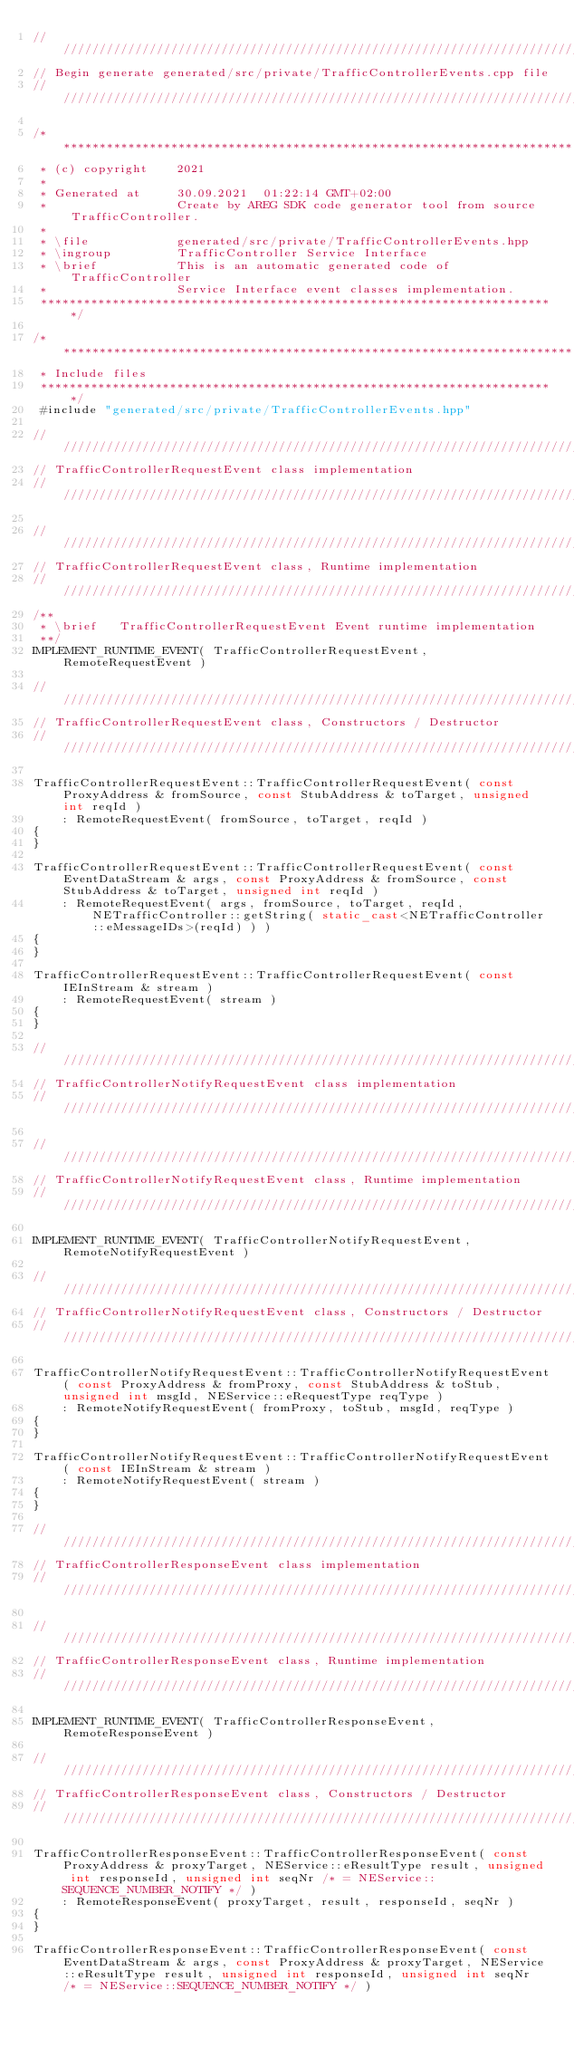<code> <loc_0><loc_0><loc_500><loc_500><_C++_>//////////////////////////////////////////////////////////////////////////
// Begin generate generated/src/private/TrafficControllerEvents.cpp file
//////////////////////////////////////////////////////////////////////////

/************************************************************************
 * (c) copyright    2021
 *
 * Generated at     30.09.2021  01:22:14 GMT+02:00 
 *                  Create by AREG SDK code generator tool from source TrafficController.
 *
 * \file            generated/src/private/TrafficControllerEvents.hpp
 * \ingroup         TrafficController Service Interface
 * \brief           This is an automatic generated code of TrafficController
 *                  Service Interface event classes implementation.
 ************************************************************************/

/************************************************************************
 * Include files
 ************************************************************************/
 #include "generated/src/private/TrafficControllerEvents.hpp"
 
//////////////////////////////////////////////////////////////////////////
// TrafficControllerRequestEvent class implementation
//////////////////////////////////////////////////////////////////////////

//////////////////////////////////////////////////////////////////////////
// TrafficControllerRequestEvent class, Runtime implementation
//////////////////////////////////////////////////////////////////////////
/**
 * \brief   TrafficControllerRequestEvent Event runtime implementation
 **/
IMPLEMENT_RUNTIME_EVENT( TrafficControllerRequestEvent, RemoteRequestEvent )

//////////////////////////////////////////////////////////////////////////
// TrafficControllerRequestEvent class, Constructors / Destructor
//////////////////////////////////////////////////////////////////////////

TrafficControllerRequestEvent::TrafficControllerRequestEvent( const ProxyAddress & fromSource, const StubAddress & toTarget, unsigned int reqId )
    : RemoteRequestEvent( fromSource, toTarget, reqId )
{
}

TrafficControllerRequestEvent::TrafficControllerRequestEvent( const EventDataStream & args, const ProxyAddress & fromSource, const StubAddress & toTarget, unsigned int reqId )
    : RemoteRequestEvent( args, fromSource, toTarget, reqId, NETrafficController::getString( static_cast<NETrafficController::eMessageIDs>(reqId) ) )
{
}

TrafficControllerRequestEvent::TrafficControllerRequestEvent( const IEInStream & stream )
    : RemoteRequestEvent( stream )
{
}    

//////////////////////////////////////////////////////////////////////////
// TrafficControllerNotifyRequestEvent class implementation
//////////////////////////////////////////////////////////////////////////

//////////////////////////////////////////////////////////////////////////
// TrafficControllerNotifyRequestEvent class, Runtime implementation
//////////////////////////////////////////////////////////////////////////

IMPLEMENT_RUNTIME_EVENT( TrafficControllerNotifyRequestEvent, RemoteNotifyRequestEvent )

//////////////////////////////////////////////////////////////////////////
// TrafficControllerNotifyRequestEvent class, Constructors / Destructor
//////////////////////////////////////////////////////////////////////////

TrafficControllerNotifyRequestEvent::TrafficControllerNotifyRequestEvent( const ProxyAddress & fromProxy, const StubAddress & toStub, unsigned int msgId, NEService::eRequestType reqType )
    : RemoteNotifyRequestEvent( fromProxy, toStub, msgId, reqType )
{
}

TrafficControllerNotifyRequestEvent::TrafficControllerNotifyRequestEvent( const IEInStream & stream )
    : RemoteNotifyRequestEvent( stream )
{
}    

//////////////////////////////////////////////////////////////////////////
// TrafficControllerResponseEvent class implementation
//////////////////////////////////////////////////////////////////////////

//////////////////////////////////////////////////////////////////////////
// TrafficControllerResponseEvent class, Runtime implementation
//////////////////////////////////////////////////////////////////////////

IMPLEMENT_RUNTIME_EVENT( TrafficControllerResponseEvent, RemoteResponseEvent )

//////////////////////////////////////////////////////////////////////////
// TrafficControllerResponseEvent class, Constructors / Destructor
//////////////////////////////////////////////////////////////////////////

TrafficControllerResponseEvent::TrafficControllerResponseEvent( const ProxyAddress & proxyTarget, NEService::eResultType result, unsigned int responseId, unsigned int seqNr /* = NEService::SEQUENCE_NUMBER_NOTIFY */ )
    : RemoteResponseEvent( proxyTarget, result, responseId, seqNr )
{
}

TrafficControllerResponseEvent::TrafficControllerResponseEvent( const EventDataStream & args, const ProxyAddress & proxyTarget, NEService::eResultType result, unsigned int responseId, unsigned int seqNr /* = NEService::SEQUENCE_NUMBER_NOTIFY */ )</code> 